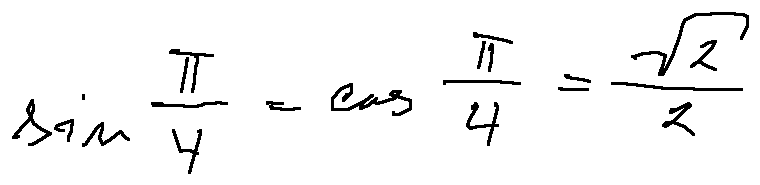<formula> <loc_0><loc_0><loc_500><loc_500>\sin \frac { \pi } { 4 } = \cos \frac { \pi } { 4 } = \frac { \sqrt { 2 } } { 2 }</formula> 